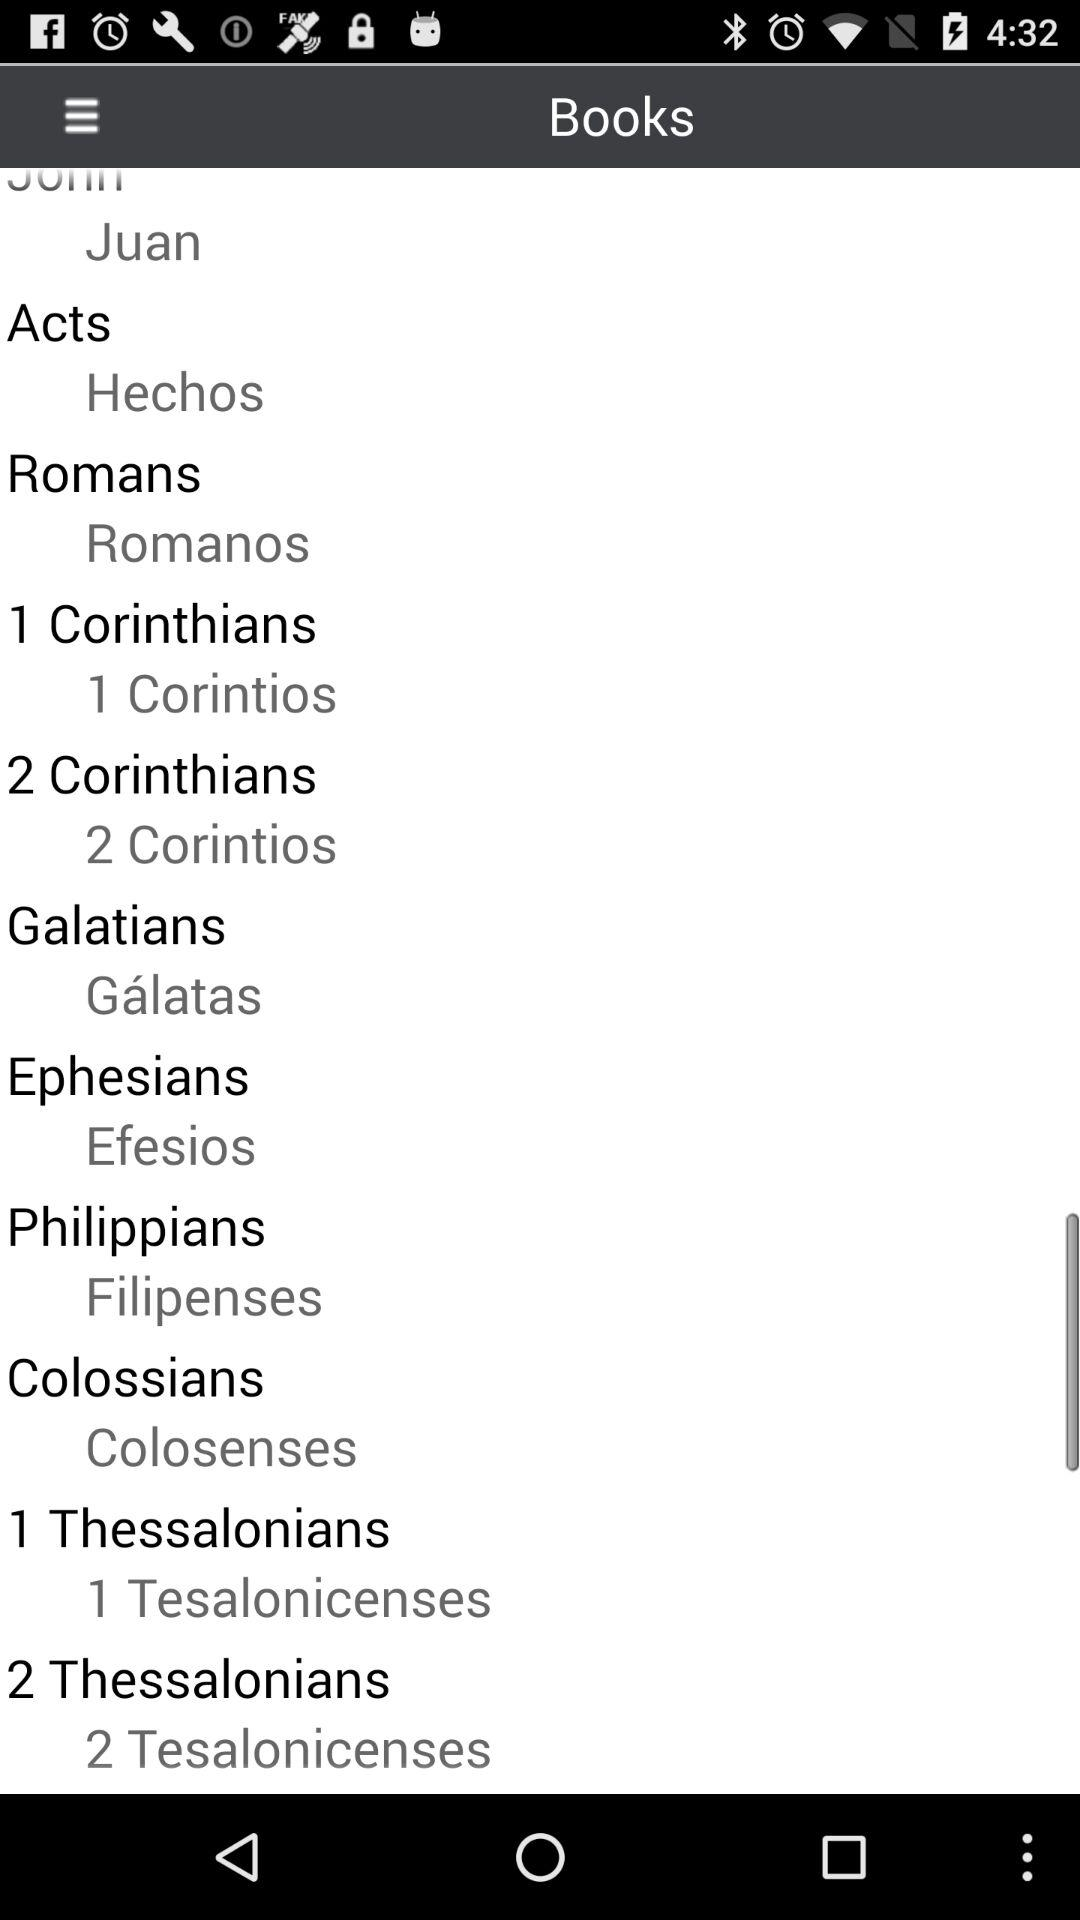What is the name of the "Colossians" book in Spanish? The name of the "Colossians" book in Spanish is "Colosenses". 